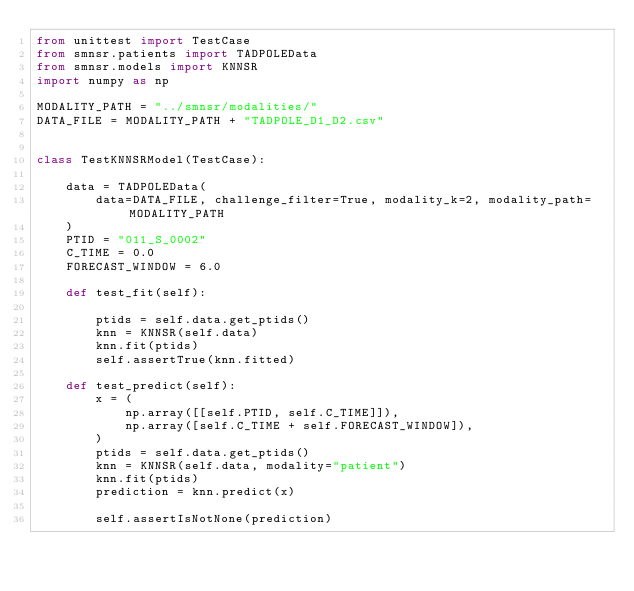Convert code to text. <code><loc_0><loc_0><loc_500><loc_500><_Python_>from unittest import TestCase
from smnsr.patients import TADPOLEData
from smnsr.models import KNNSR
import numpy as np

MODALITY_PATH = "../smnsr/modalities/"
DATA_FILE = MODALITY_PATH + "TADPOLE_D1_D2.csv"


class TestKNNSRModel(TestCase):

    data = TADPOLEData(
        data=DATA_FILE, challenge_filter=True, modality_k=2, modality_path=MODALITY_PATH
    )
    PTID = "011_S_0002"
    C_TIME = 0.0
    FORECAST_WINDOW = 6.0

    def test_fit(self):

        ptids = self.data.get_ptids()
        knn = KNNSR(self.data)
        knn.fit(ptids)
        self.assertTrue(knn.fitted)

    def test_predict(self):
        x = (
            np.array([[self.PTID, self.C_TIME]]),
            np.array([self.C_TIME + self.FORECAST_WINDOW]),
        )
        ptids = self.data.get_ptids()
        knn = KNNSR(self.data, modality="patient")
        knn.fit(ptids)
        prediction = knn.predict(x)

        self.assertIsNotNone(prediction)
</code> 